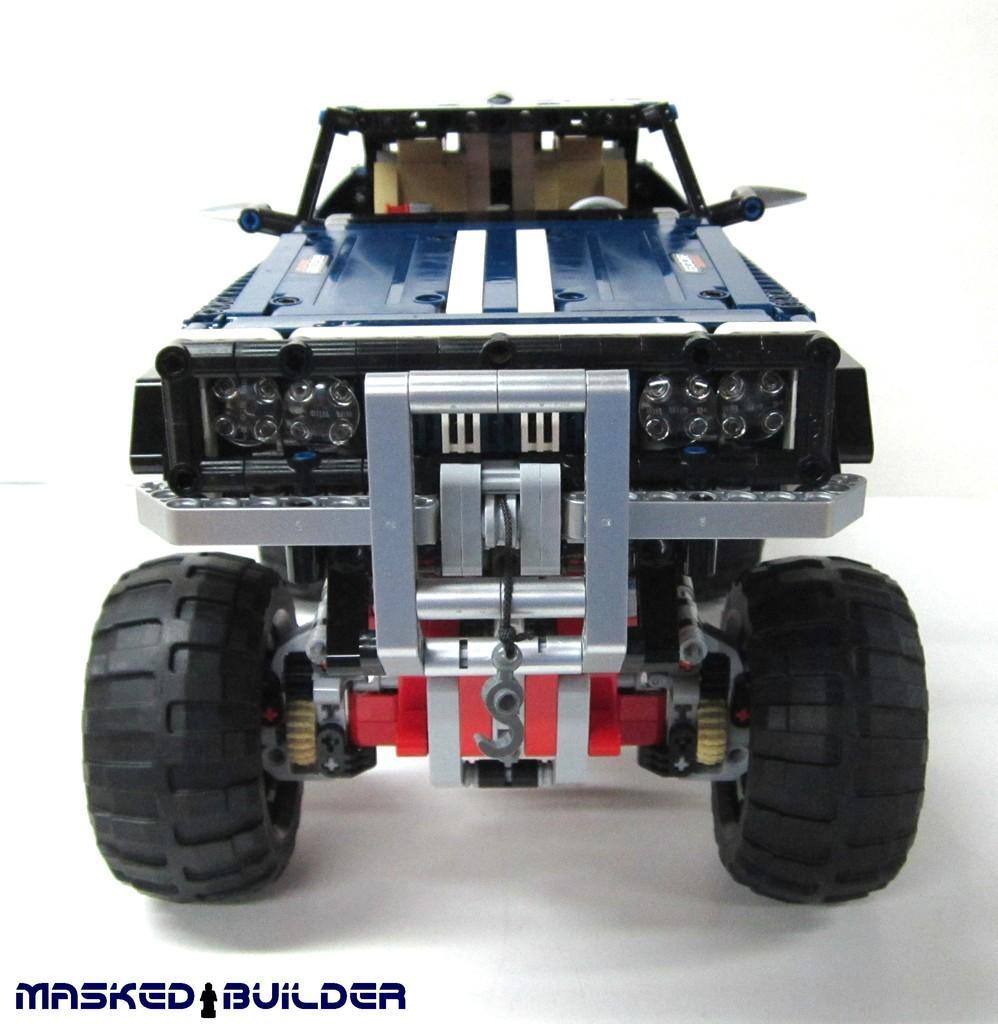Describe this image in one or two sentences. In the center of the image there is a depiction of a car. 